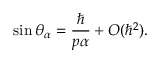Convert formula to latex. <formula><loc_0><loc_0><loc_500><loc_500>\sin \theta _ { \alpha } = \frac { } { p \alpha } + O ( \hbar { ^ } { 2 } ) .</formula> 